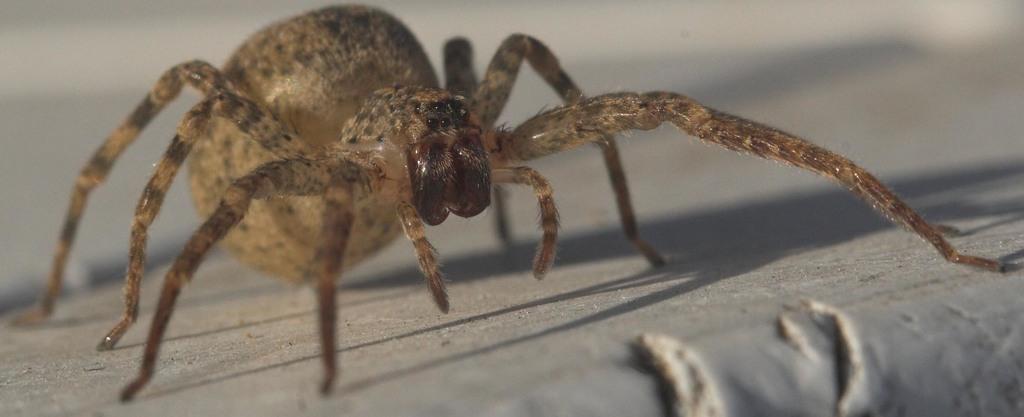In one or two sentences, can you explain what this image depicts? In this image I can see a spider on the ground. 